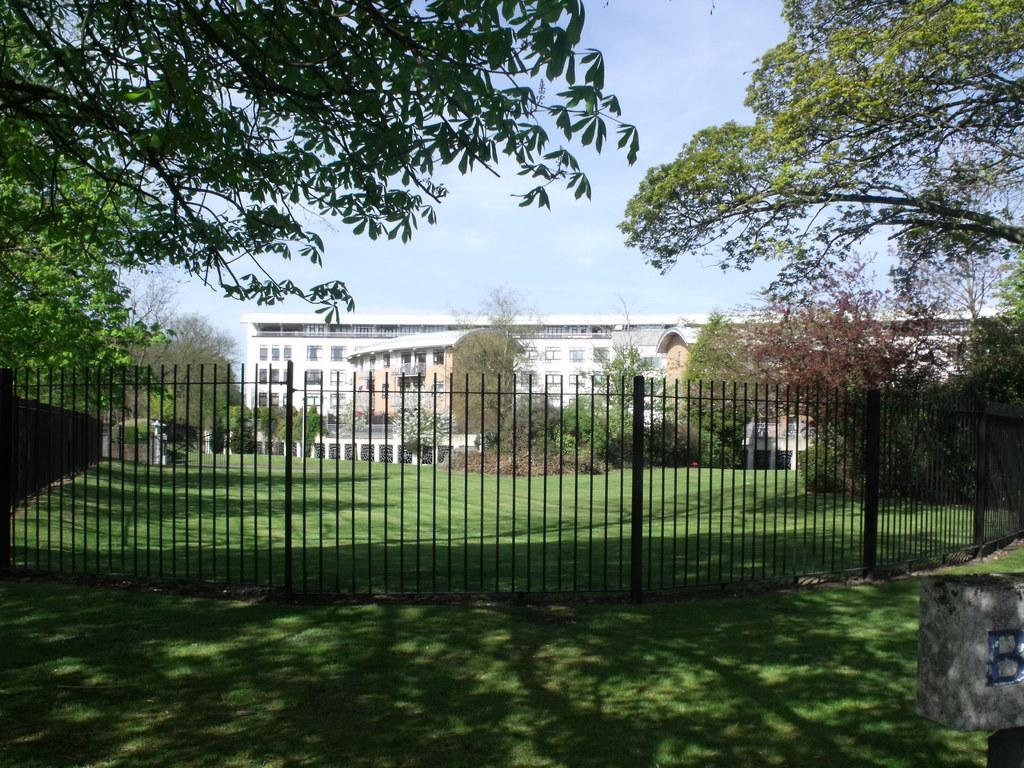What type of structure is present in the image? There is a building in the image. What can be seen surrounding the building? There is a fence and trees in the image. What is visible in the background of the image? The sky is visible in the background of the image. What type of ground cover is present at the bottom of the image? There is grass at the bottom of the image. What type of fruit can be seen growing on the building in the image? There is no fruit growing on the building in the image. What type of bun is present on the fence in the image? There is no bun present on the fence in the image. 